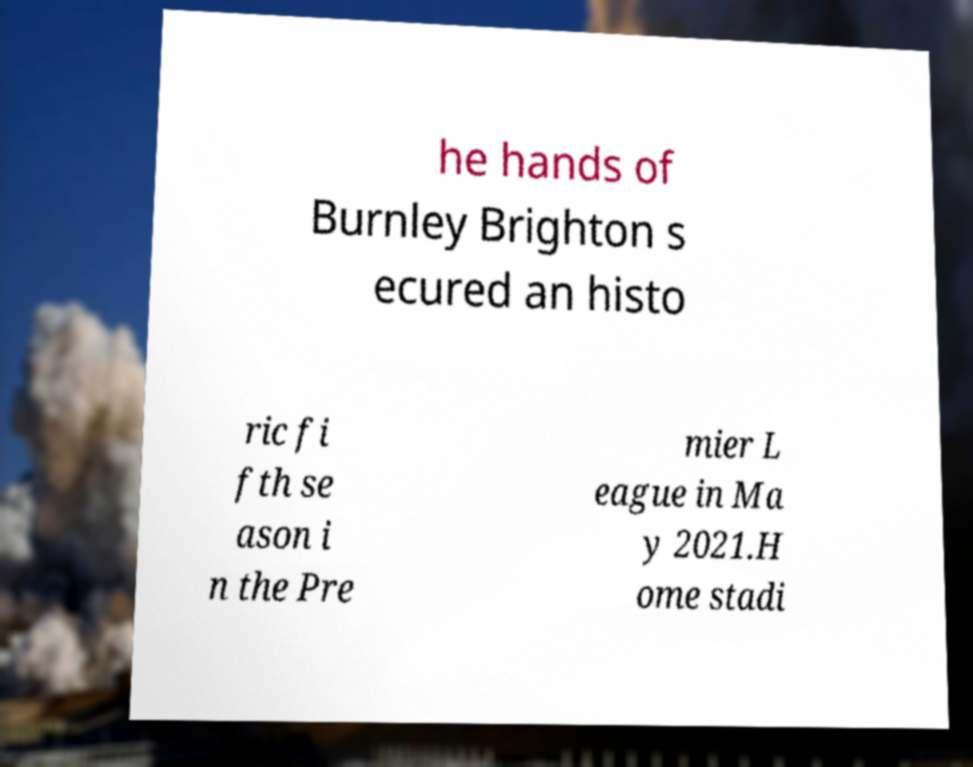There's text embedded in this image that I need extracted. Can you transcribe it verbatim? he hands of Burnley Brighton s ecured an histo ric fi fth se ason i n the Pre mier L eague in Ma y 2021.H ome stadi 